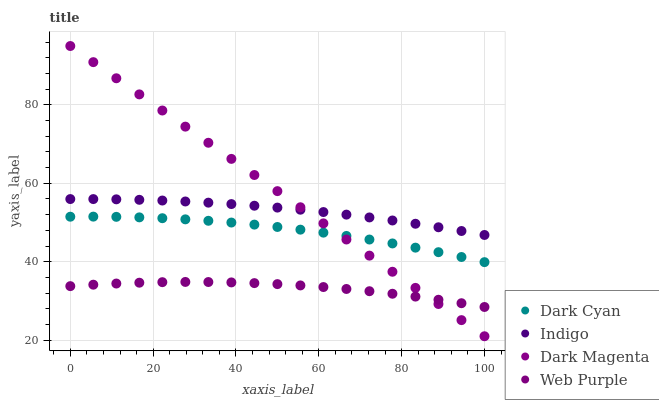Does Web Purple have the minimum area under the curve?
Answer yes or no. Yes. Does Dark Magenta have the maximum area under the curve?
Answer yes or no. Yes. Does Indigo have the minimum area under the curve?
Answer yes or no. No. Does Indigo have the maximum area under the curve?
Answer yes or no. No. Is Dark Magenta the smoothest?
Answer yes or no. Yes. Is Dark Cyan the roughest?
Answer yes or no. Yes. Is Web Purple the smoothest?
Answer yes or no. No. Is Web Purple the roughest?
Answer yes or no. No. Does Dark Magenta have the lowest value?
Answer yes or no. Yes. Does Web Purple have the lowest value?
Answer yes or no. No. Does Dark Magenta have the highest value?
Answer yes or no. Yes. Does Indigo have the highest value?
Answer yes or no. No. Is Web Purple less than Indigo?
Answer yes or no. Yes. Is Indigo greater than Web Purple?
Answer yes or no. Yes. Does Dark Magenta intersect Indigo?
Answer yes or no. Yes. Is Dark Magenta less than Indigo?
Answer yes or no. No. Is Dark Magenta greater than Indigo?
Answer yes or no. No. Does Web Purple intersect Indigo?
Answer yes or no. No. 